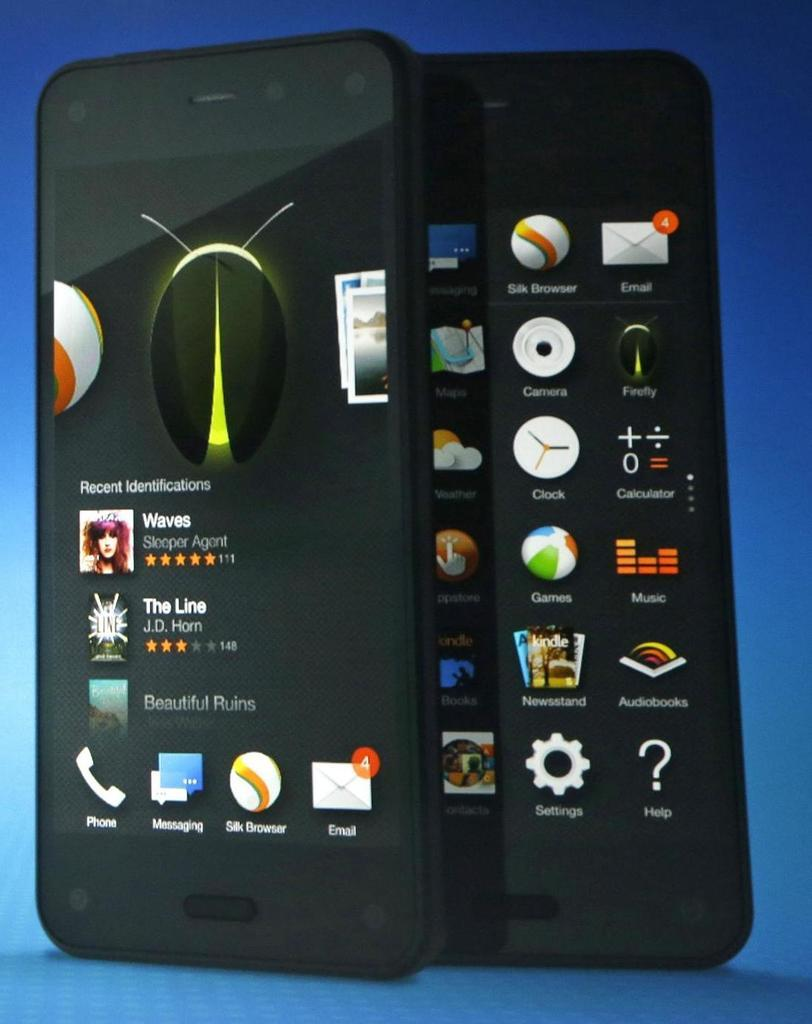<image>
Present a compact description of the photo's key features. A cell phone with a listing of Recent Identifications on it. 